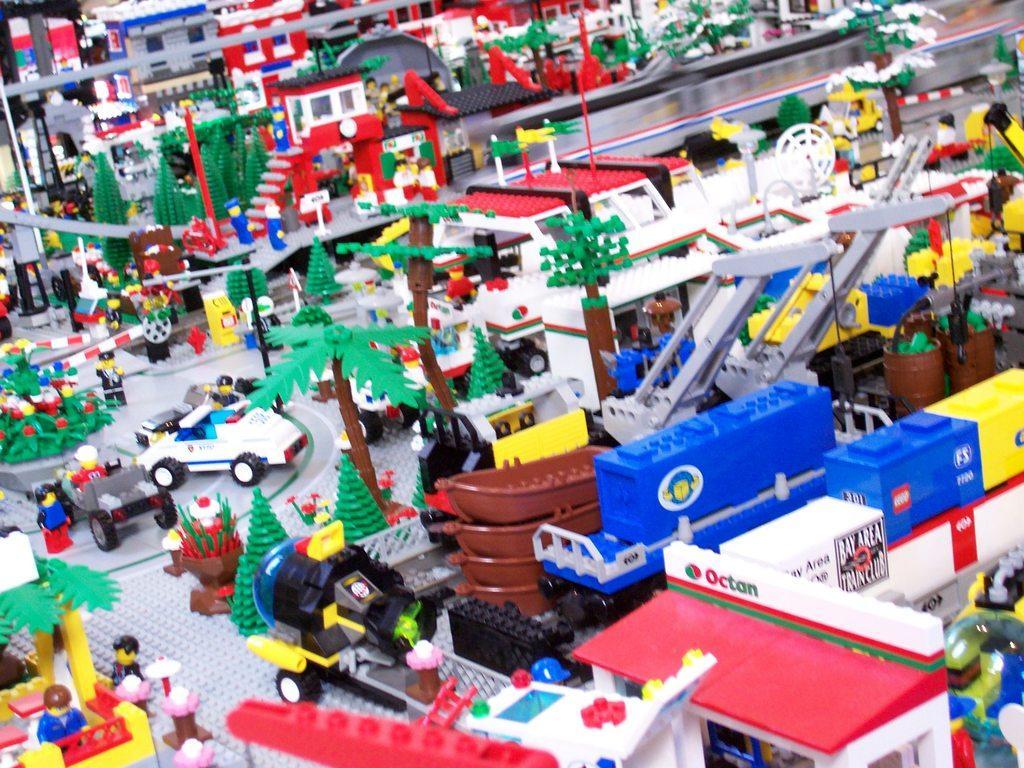How would you summarize this image in a sentence or two? In this image, we can see some toys like vehicle, car, person's, trees, road and few buildings. 